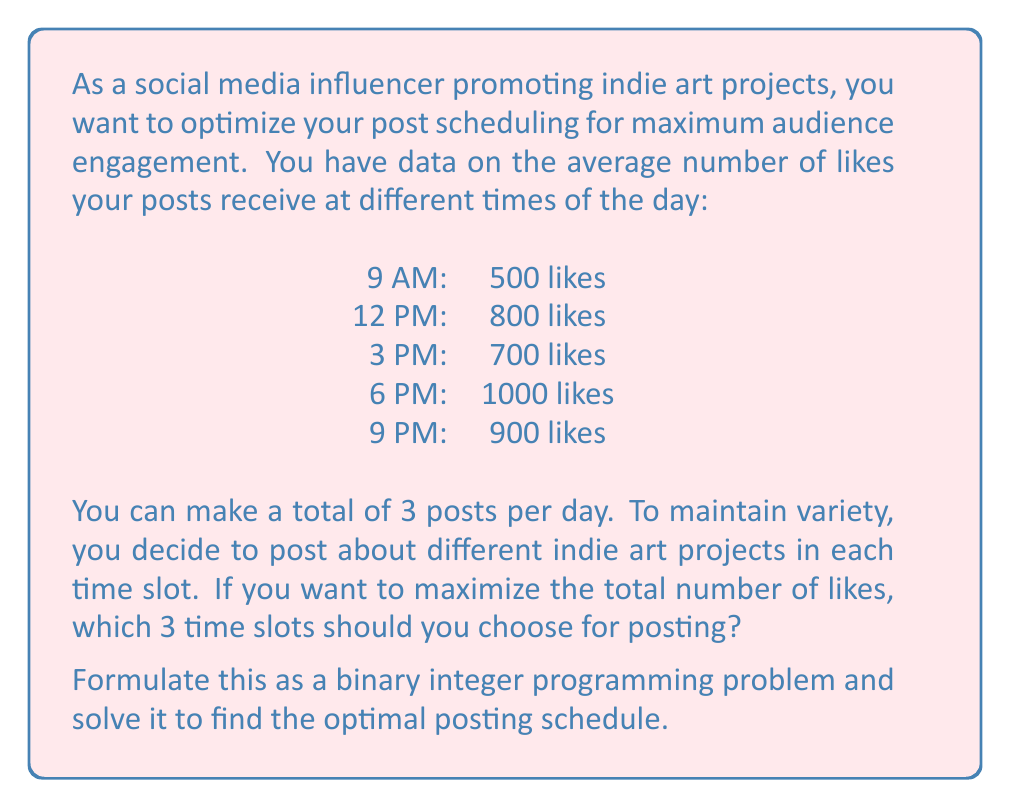Can you answer this question? To solve this problem, we'll use binary integer programming. Let's define our decision variables:

$x_1$ = 1 if we post at 9 AM, 0 otherwise
$x_2$ = 1 if we post at 12 PM, 0 otherwise
$x_3$ = 1 if we post at 3 PM, 0 otherwise
$x_4$ = 1 if we post at 6 PM, 0 otherwise
$x_5$ = 1 if we post at 9 PM, 0 otherwise

Our objective function is to maximize the total number of likes:

$$\text{Maximize } 500x_1 + 800x_2 + 700x_3 + 1000x_4 + 900x_5$$

Subject to the constraint that we can only make 3 posts:

$$x_1 + x_2 + x_3 + x_4 + x_5 = 3$$

And each $x_i$ is binary (0 or 1).

To solve this, we can use the following steps:

1. List all possible combinations of 3 time slots out of 5.
2. Calculate the total likes for each combination.
3. Choose the combination with the maximum total likes.

Possible combinations and their total likes:

1. 9 AM, 12 PM, 3 PM: 500 + 800 + 700 = 2000
2. 9 AM, 12 PM, 6 PM: 500 + 800 + 1000 = 2300
3. 9 AM, 12 PM, 9 PM: 500 + 800 + 900 = 2200
4. 9 AM, 3 PM, 6 PM: 500 + 700 + 1000 = 2200
5. 9 AM, 3 PM, 9 PM: 500 + 700 + 900 = 2100
6. 9 AM, 6 PM, 9 PM: 500 + 1000 + 900 = 2400
7. 12 PM, 3 PM, 6 PM: 800 + 700 + 1000 = 2500
8. 12 PM, 3 PM, 9 PM: 800 + 700 + 900 = 2400
9. 12 PM, 6 PM, 9 PM: 800 + 1000 + 900 = 2700
10. 3 PM, 6 PM, 9 PM: 700 + 1000 + 900 = 2600

The maximum total likes is 2700, achieved by posting at 12 PM, 6 PM, and 9 PM.
Answer: The optimal posting schedule is:
12 PM, 6 PM, and 9 PM

This schedule maximizes the total number of likes at 2700.

In terms of our decision variables:
$x_1 = 0$, $x_2 = 1$, $x_3 = 0$, $x_4 = 1$, $x_5 = 1$ 